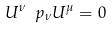Convert formula to latex. <formula><loc_0><loc_0><loc_500><loc_500>U ^ { \nu } \ p _ { \nu } U ^ { \mu } = 0</formula> 